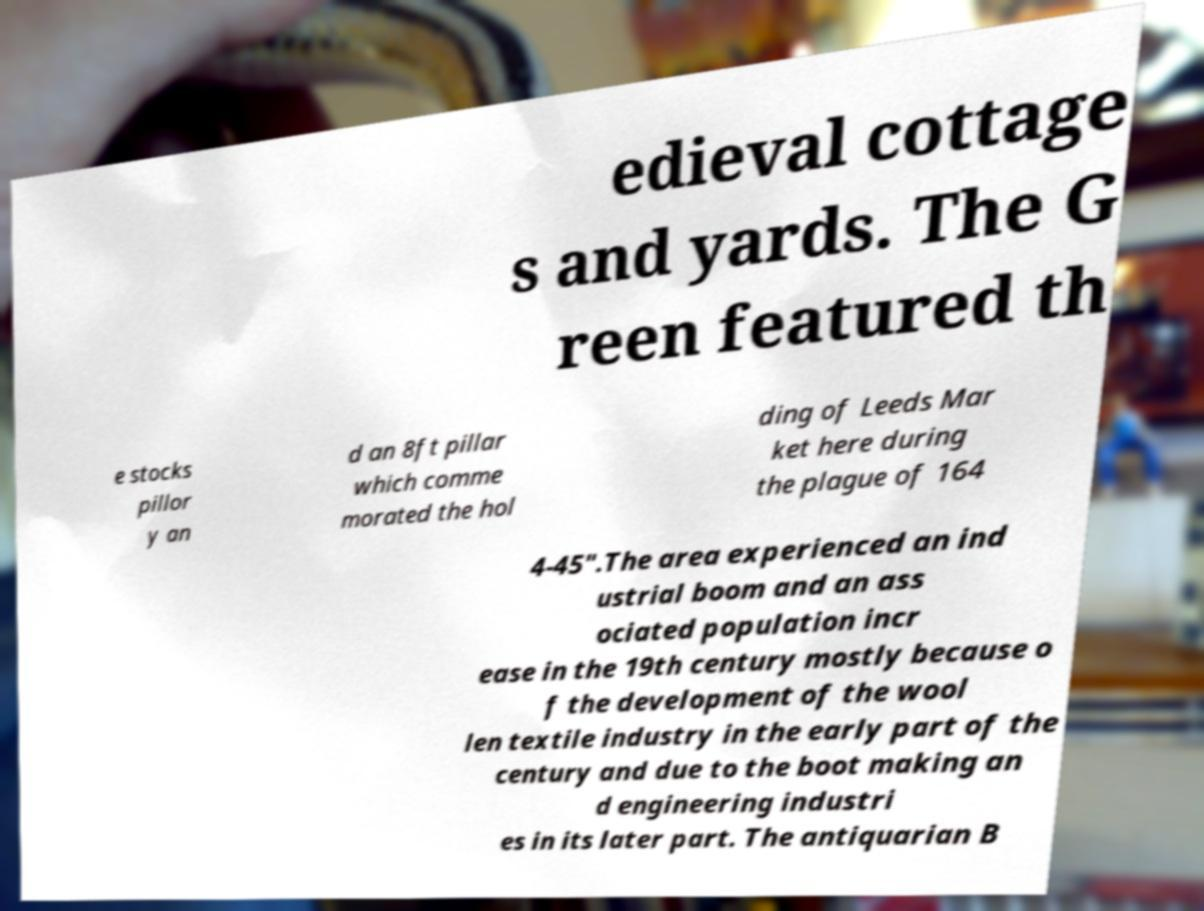What messages or text are displayed in this image? I need them in a readable, typed format. edieval cottage s and yards. The G reen featured th e stocks pillor y an d an 8ft pillar which comme morated the hol ding of Leeds Mar ket here during the plague of 164 4-45".The area experienced an ind ustrial boom and an ass ociated population incr ease in the 19th century mostly because o f the development of the wool len textile industry in the early part of the century and due to the boot making an d engineering industri es in its later part. The antiquarian B 